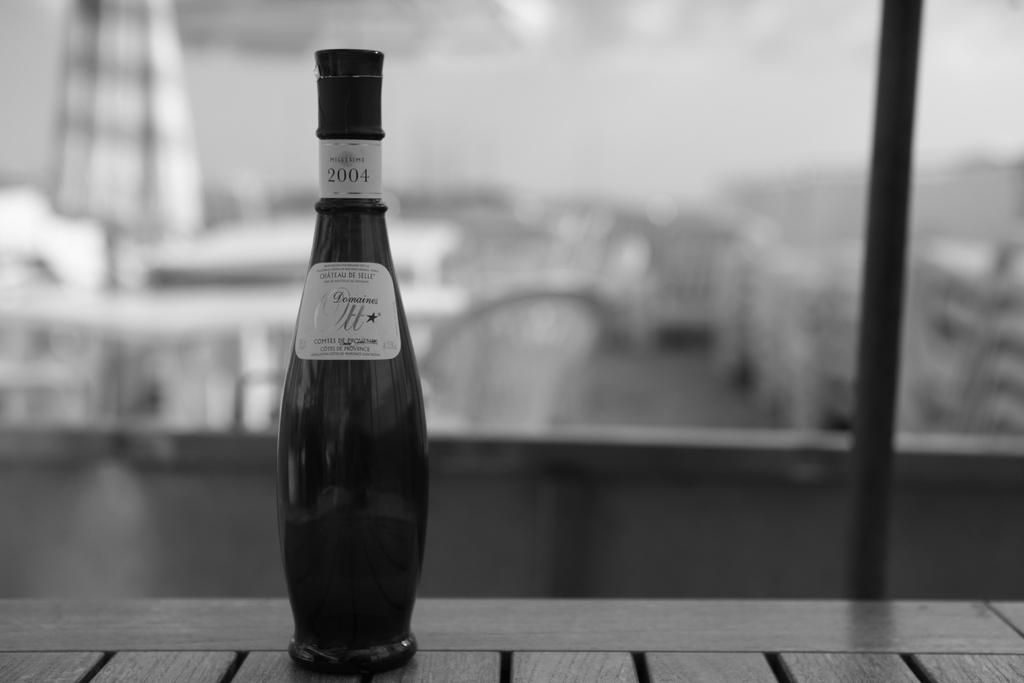What year is this bottle?
Provide a short and direct response. 2004. 